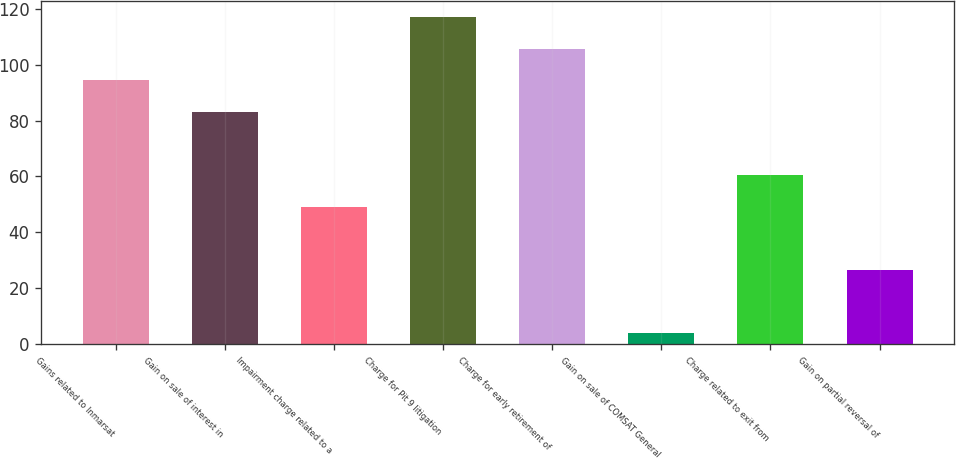Convert chart. <chart><loc_0><loc_0><loc_500><loc_500><bar_chart><fcel>Gains related to Inmarsat<fcel>Gain on sale of interest in<fcel>Impairment charge related to a<fcel>Charge for Pit 9 litigation<fcel>Charge for early retirement of<fcel>Gain on sale of COMSAT General<fcel>Charge related to exit from<fcel>Gain on partial reversal of<nl><fcel>94.4<fcel>83.1<fcel>49.2<fcel>117<fcel>105.7<fcel>4<fcel>60.5<fcel>26.6<nl></chart> 